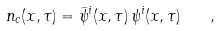<formula> <loc_0><loc_0><loc_500><loc_500>n _ { c } ( { x } , \tau ) = { \bar { \psi } } ^ { i } ( { x } , \tau ) \, \psi ^ { i } ( { x } , \tau ) \quad ,</formula> 